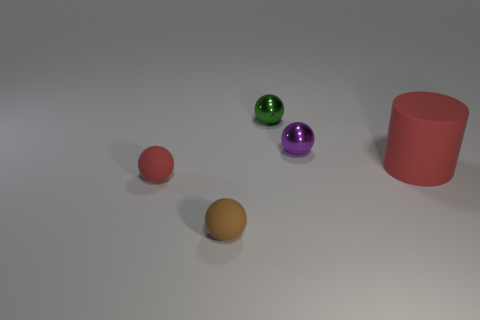Add 5 brown shiny things. How many objects exist? 10 Subtract all spheres. How many objects are left? 1 Add 4 small spheres. How many small spheres are left? 8 Add 3 cyan metallic cubes. How many cyan metallic cubes exist? 3 Subtract 0 green cylinders. How many objects are left? 5 Subtract all tiny green balls. Subtract all tiny brown rubber objects. How many objects are left? 3 